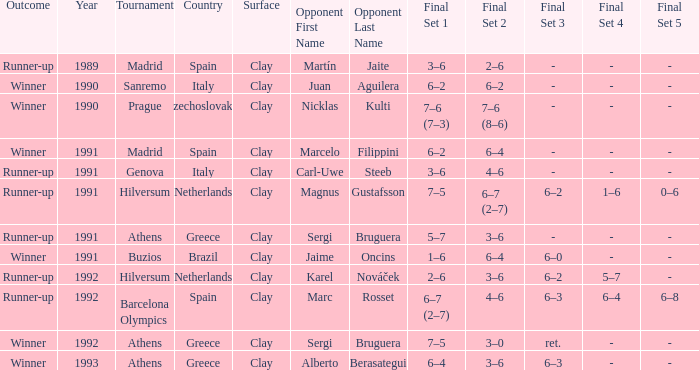What is Score In The Final, when Championship is "Athens , Greece", and when Outcome is "Winner"? 7–5, 3–0, ret., 6–4, 3–6, 6–3. 